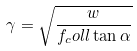Convert formula to latex. <formula><loc_0><loc_0><loc_500><loc_500>\gamma = \sqrt { \frac { w } { f _ { c } o l l \tan \alpha } }</formula> 